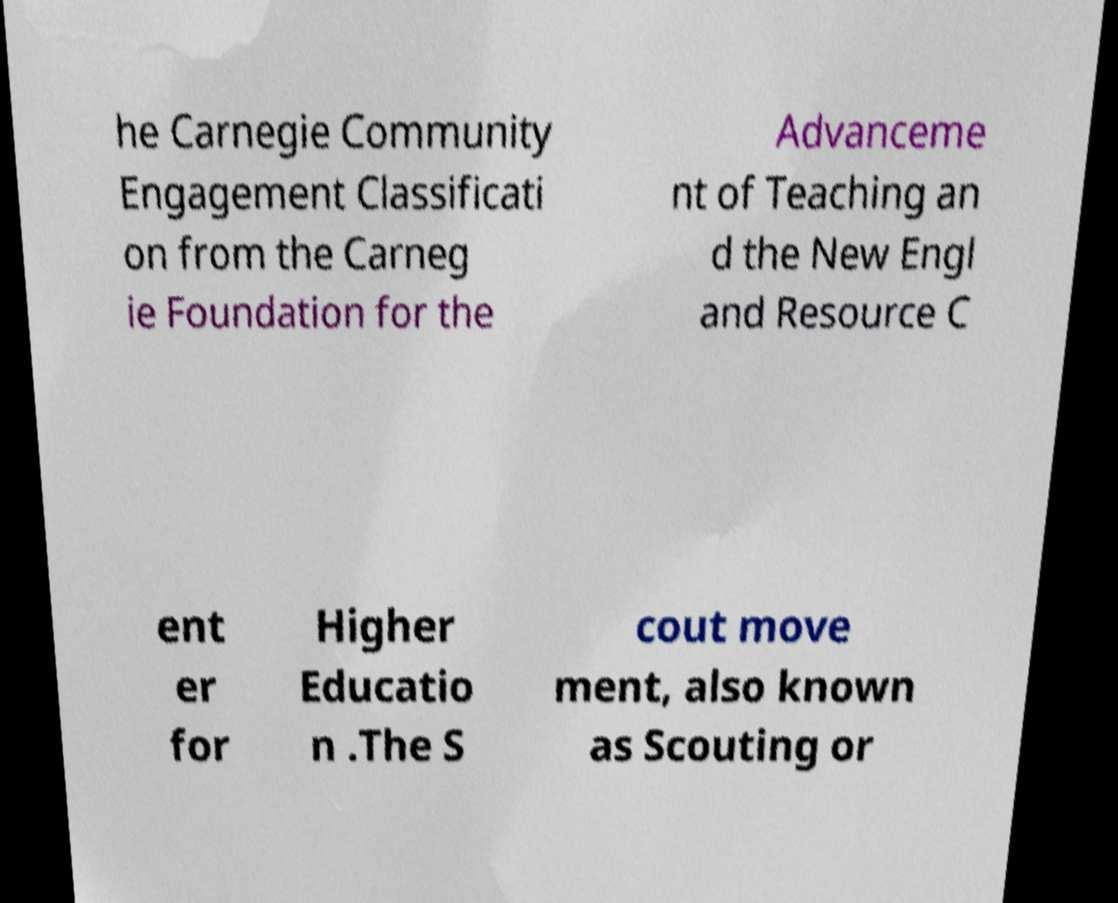Please read and relay the text visible in this image. What does it say? he Carnegie Community Engagement Classificati on from the Carneg ie Foundation for the Advanceme nt of Teaching an d the New Engl and Resource C ent er for Higher Educatio n .The S cout move ment, also known as Scouting or 